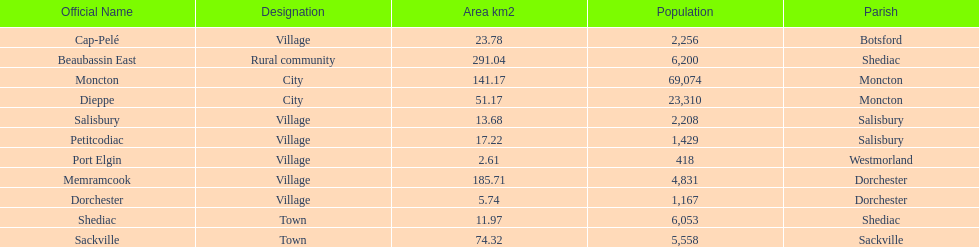Which city has the least area Port Elgin. 